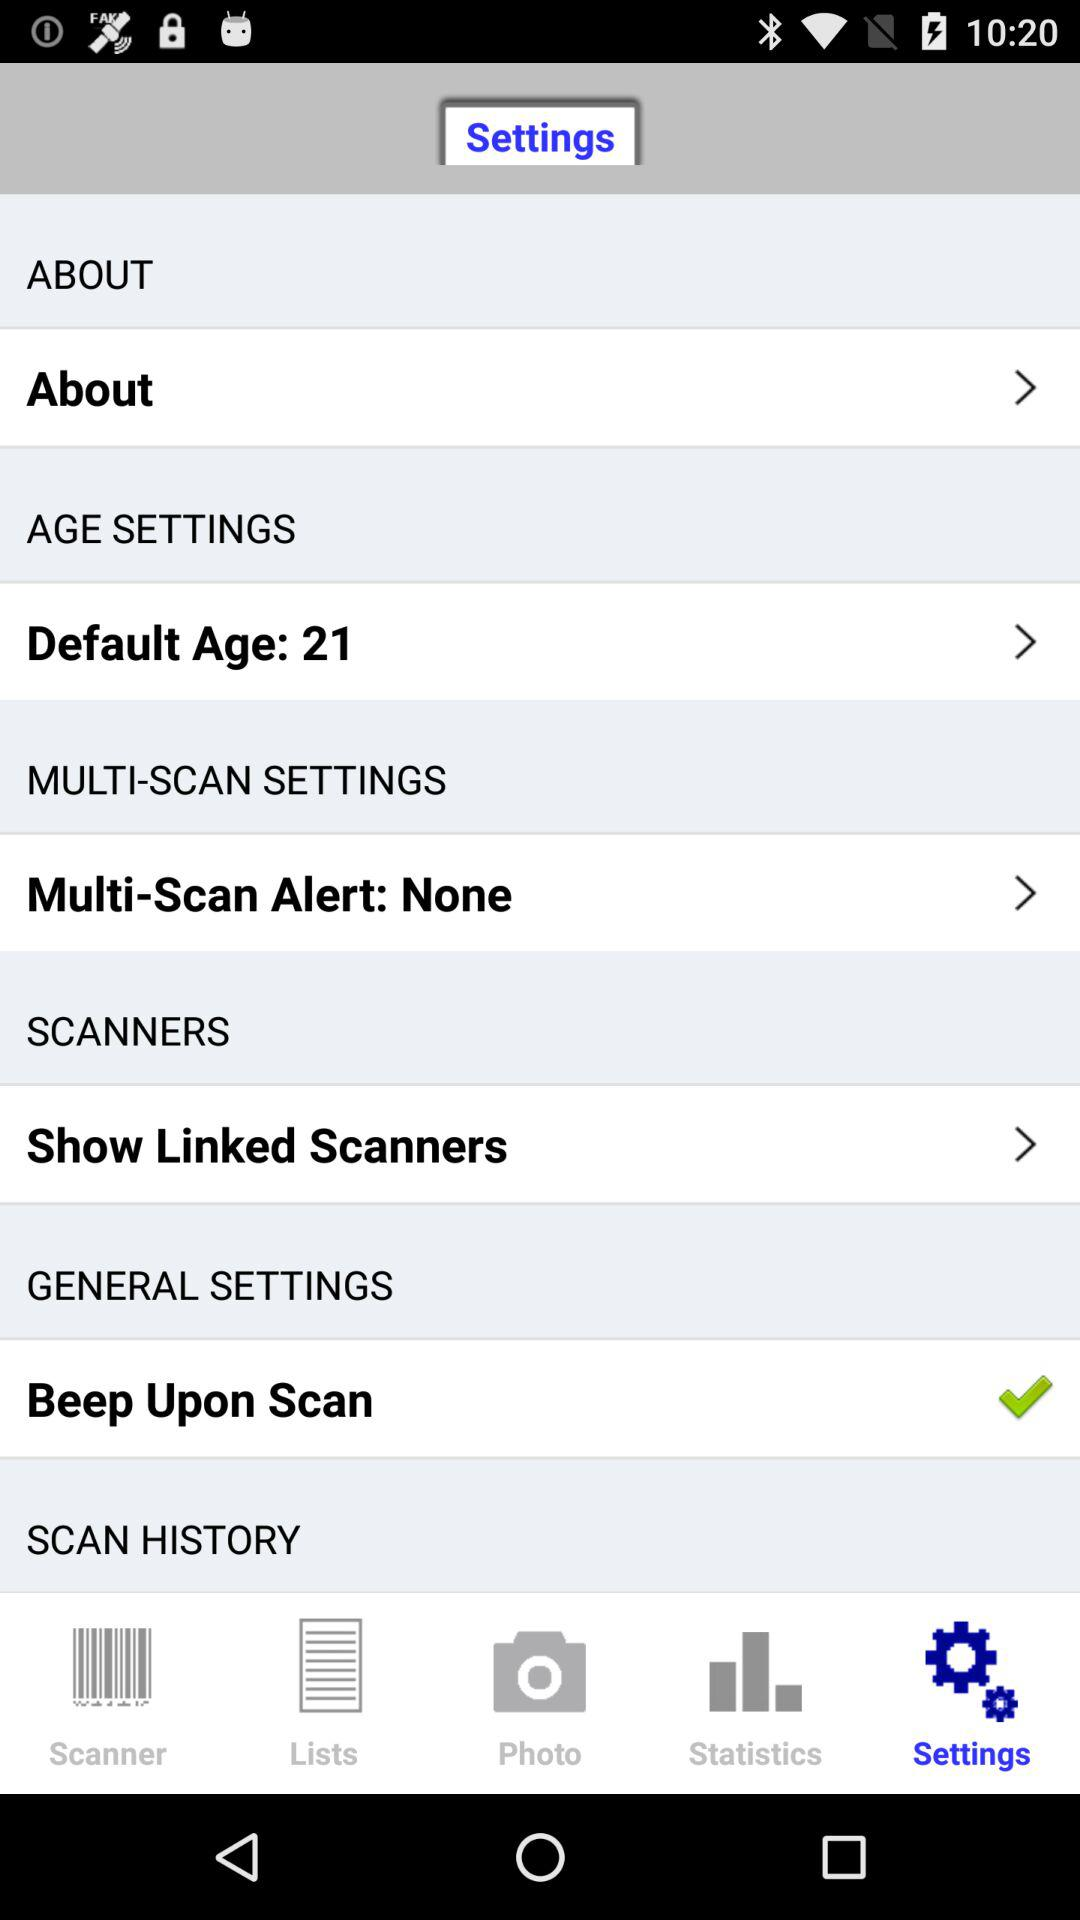What's the setting for the multi-scan alert? The setting for the multi-scan alert is "None". 